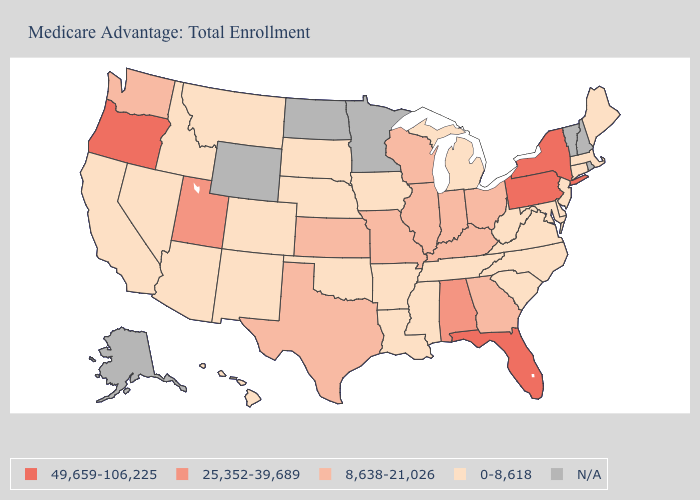Among the states that border Montana , which have the highest value?
Quick response, please. Idaho, South Dakota. Name the states that have a value in the range 49,659-106,225?
Keep it brief. Florida, New York, Oregon, Pennsylvania. Among the states that border Ohio , which have the lowest value?
Be succinct. Michigan, West Virginia. What is the highest value in the USA?
Be succinct. 49,659-106,225. What is the value of Florida?
Answer briefly. 49,659-106,225. Among the states that border Montana , which have the highest value?
Write a very short answer. Idaho, South Dakota. Which states hav the highest value in the West?
Give a very brief answer. Oregon. Does the first symbol in the legend represent the smallest category?
Be succinct. No. What is the highest value in the USA?
Answer briefly. 49,659-106,225. Name the states that have a value in the range 8,638-21,026?
Write a very short answer. Georgia, Illinois, Indiana, Kansas, Kentucky, Missouri, Ohio, Texas, Washington, Wisconsin. What is the value of Georgia?
Write a very short answer. 8,638-21,026. Does Maine have the highest value in the Northeast?
Concise answer only. No. Does Oklahoma have the highest value in the USA?
Be succinct. No. Does Massachusetts have the lowest value in the Northeast?
Keep it brief. Yes. 